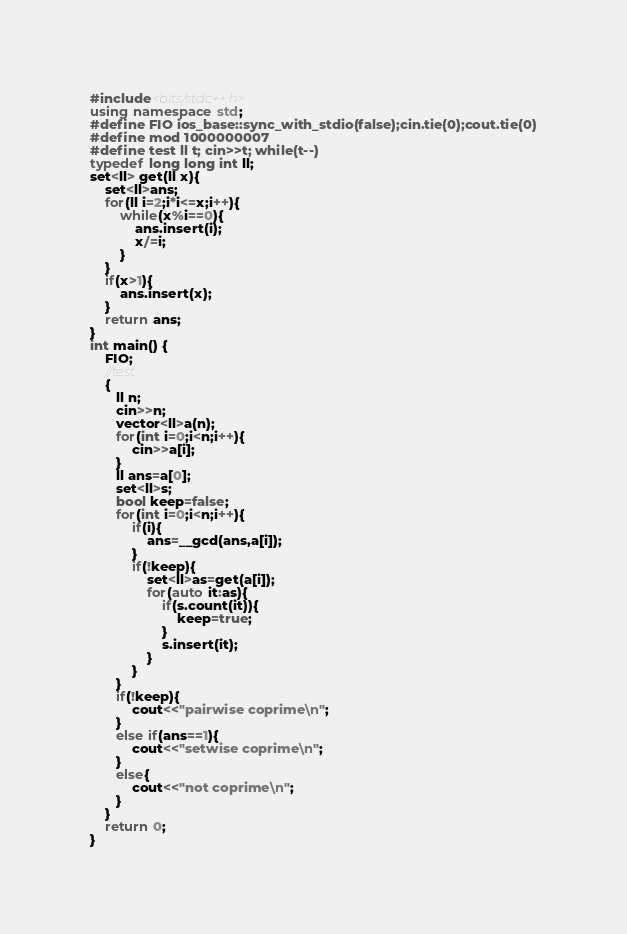<code> <loc_0><loc_0><loc_500><loc_500><_C++_>#include<bits/stdc++.h>
using namespace std;
#define FIO ios_base::sync_with_stdio(false);cin.tie(0);cout.tie(0)
#define mod 1000000007
#define test ll t; cin>>t; while(t--)
typedef long long int ll;
set<ll> get(ll x){
    set<ll>ans;
    for(ll i=2;i*i<=x;i++){
        while(x%i==0){
            ans.insert(i);
            x/=i;
        }
    }
    if(x>1){
        ans.insert(x);
    }
    return ans;
}
int main() {
    FIO;
    //test
    {
       ll n;
       cin>>n;
       vector<ll>a(n);
       for(int i=0;i<n;i++){
           cin>>a[i];
       }
       ll ans=a[0];
       set<ll>s;
       bool keep=false;
       for(int i=0;i<n;i++){
           if(i){
               ans=__gcd(ans,a[i]);
           }
           if(!keep){
               set<ll>as=get(a[i]);
               for(auto it:as){
                   if(s.count(it)){
                       keep=true;
                   }
                   s.insert(it);
               }
           }
       }
       if(!keep){
           cout<<"pairwise coprime\n";
       }
       else if(ans==1){
           cout<<"setwise coprime\n";
       }
       else{
           cout<<"not coprime\n";
       }
    }
	return 0;
}
</code> 